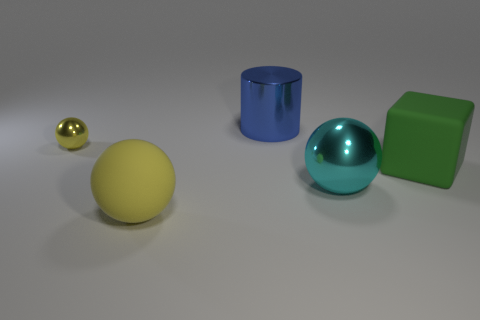What shape is the large object that is on the left side of the big green rubber thing and right of the big metal cylinder?
Offer a terse response. Sphere. What number of yellow objects are shiny spheres or large metallic objects?
Provide a short and direct response. 1. Does the metal object on the left side of the large yellow sphere have the same color as the large rubber ball?
Your response must be concise. Yes. There is a yellow thing that is behind the ball on the right side of the blue metal cylinder; what size is it?
Make the answer very short. Small. There is a yellow thing that is the same size as the matte cube; what is it made of?
Give a very brief answer. Rubber. How many other things are there of the same size as the yellow shiny ball?
Give a very brief answer. 0. How many blocks are either large metallic things or big rubber things?
Give a very brief answer. 1. What material is the big ball that is left of the big thing behind the metal sphere that is left of the large cylinder made of?
Ensure brevity in your answer.  Rubber. What is the material of the big object that is the same color as the small sphere?
Offer a very short reply. Rubber. How many other cyan objects have the same material as the tiny object?
Ensure brevity in your answer.  1. 